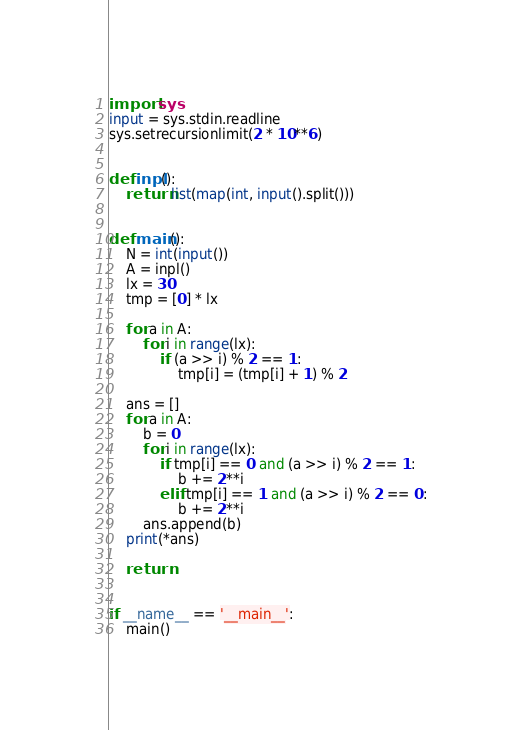Convert code to text. <code><loc_0><loc_0><loc_500><loc_500><_Python_>import sys
input = sys.stdin.readline
sys.setrecursionlimit(2 * 10**6)


def inpl():
    return list(map(int, input().split()))


def main():
    N = int(input())
    A = inpl()
    lx = 30
    tmp = [0] * lx

    for a in A:
        for i in range(lx):
            if (a >> i) % 2 == 1:
                tmp[i] = (tmp[i] + 1) % 2

    ans = []
    for a in A:
        b = 0
        for i in range(lx):
            if tmp[i] == 0 and (a >> i) % 2 == 1:
                b += 2**i
            elif tmp[i] == 1 and (a >> i) % 2 == 0:
                b += 2**i
        ans.append(b)
    print(*ans)

    return


if __name__ == '__main__':
    main()
</code> 